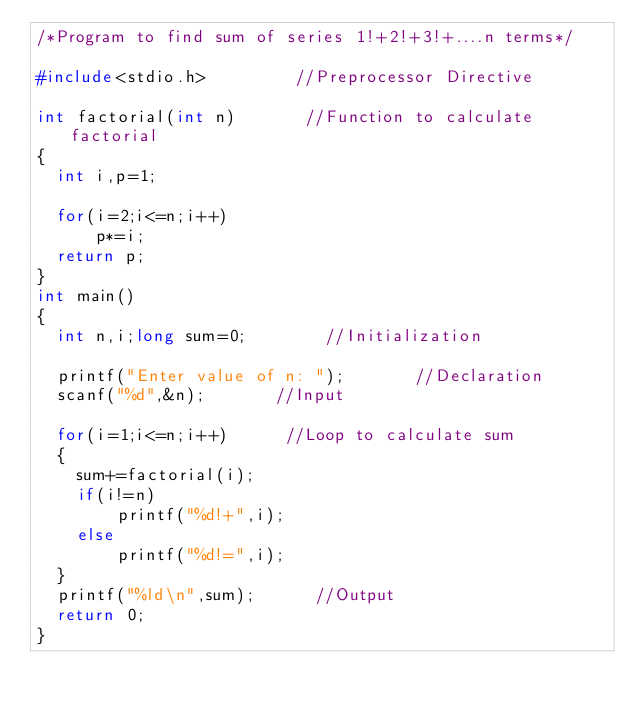Convert code to text. <code><loc_0><loc_0><loc_500><loc_500><_C_>/*Program to find sum of series 1!+2!+3!+....n terms*/

#include<stdio.h>         //Preprocessor Directive

int factorial(int n)       //Function to calculate factorial
{
	int i,p=1;
	
	for(i=2;i<=n;i++)
	    p*=i;
	return p;
}
int main()
{
	int n,i;long sum=0;        //Initialization
	
	printf("Enter value of n: ");       //Declaration
	scanf("%d",&n);       //Input
	
	for(i=1;i<=n;i++)      //Loop to calculate sum
	{
		sum+=factorial(i);
		if(i!=n)
		    printf("%d!+",i);
		else
		    printf("%d!=",i);
	}
	printf("%ld\n",sum);      //Output
	return 0;
}
</code> 